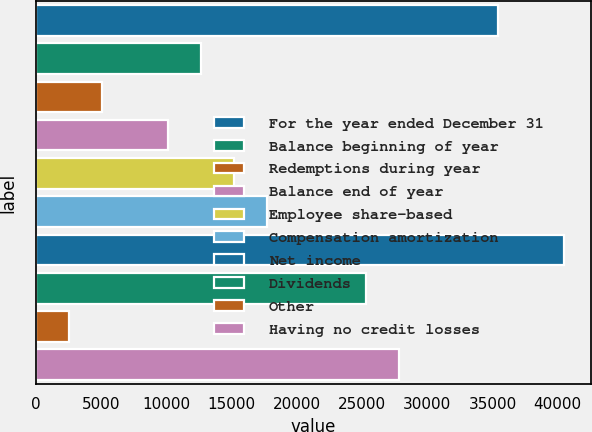Convert chart. <chart><loc_0><loc_0><loc_500><loc_500><bar_chart><fcel>For the year ended December 31<fcel>Balance beginning of year<fcel>Redemptions during year<fcel>Balance end of year<fcel>Employee share-based<fcel>Compensation amortization<fcel>Net income<fcel>Dividends<fcel>Other<fcel>Having no credit losses<nl><fcel>35445.7<fcel>12660.6<fcel>5065.64<fcel>10129<fcel>15192.3<fcel>17724<fcel>40509<fcel>25319<fcel>2533.97<fcel>27850.7<nl></chart> 